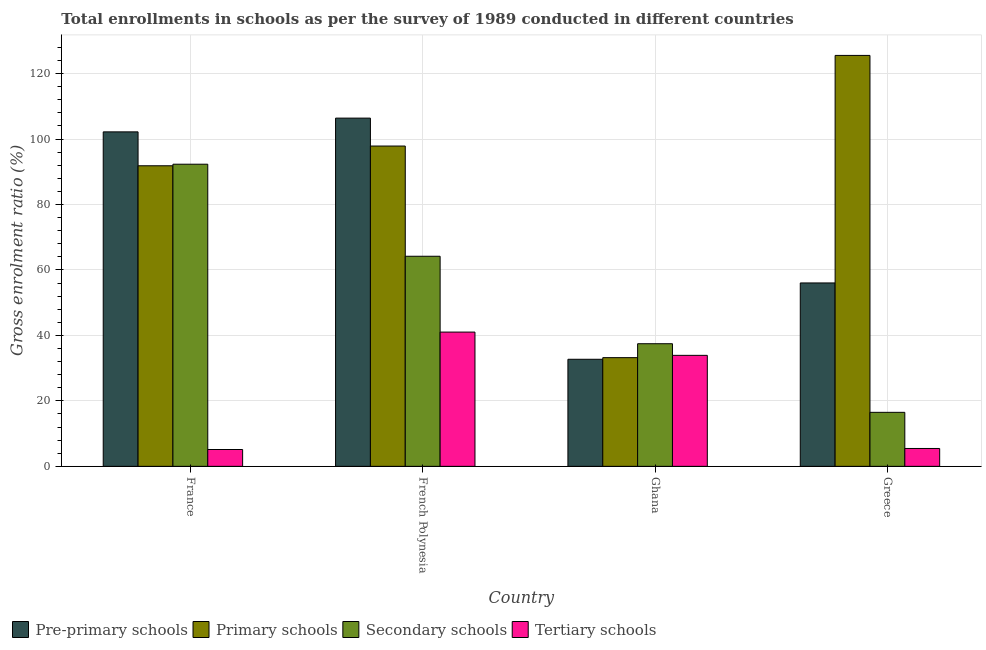How many bars are there on the 4th tick from the left?
Provide a short and direct response. 4. What is the label of the 3rd group of bars from the left?
Give a very brief answer. Ghana. In how many cases, is the number of bars for a given country not equal to the number of legend labels?
Provide a succinct answer. 0. What is the gross enrolment ratio in primary schools in French Polynesia?
Your answer should be very brief. 97.86. Across all countries, what is the maximum gross enrolment ratio in pre-primary schools?
Provide a succinct answer. 106.39. Across all countries, what is the minimum gross enrolment ratio in secondary schools?
Ensure brevity in your answer.  16.5. In which country was the gross enrolment ratio in secondary schools maximum?
Make the answer very short. France. What is the total gross enrolment ratio in pre-primary schools in the graph?
Offer a terse response. 297.32. What is the difference between the gross enrolment ratio in secondary schools in Ghana and that in Greece?
Your answer should be very brief. 20.96. What is the difference between the gross enrolment ratio in secondary schools in Ghana and the gross enrolment ratio in pre-primary schools in France?
Your answer should be very brief. -64.73. What is the average gross enrolment ratio in tertiary schools per country?
Offer a very short reply. 21.38. What is the difference between the gross enrolment ratio in secondary schools and gross enrolment ratio in primary schools in French Polynesia?
Your answer should be very brief. -33.67. In how many countries, is the gross enrolment ratio in tertiary schools greater than 88 %?
Your answer should be compact. 0. What is the ratio of the gross enrolment ratio in pre-primary schools in Ghana to that in Greece?
Your answer should be compact. 0.58. Is the gross enrolment ratio in primary schools in French Polynesia less than that in Greece?
Offer a very short reply. Yes. Is the difference between the gross enrolment ratio in secondary schools in French Polynesia and Ghana greater than the difference between the gross enrolment ratio in primary schools in French Polynesia and Ghana?
Give a very brief answer. No. What is the difference between the highest and the second highest gross enrolment ratio in primary schools?
Keep it short and to the point. 27.68. What is the difference between the highest and the lowest gross enrolment ratio in pre-primary schools?
Make the answer very short. 73.68. In how many countries, is the gross enrolment ratio in pre-primary schools greater than the average gross enrolment ratio in pre-primary schools taken over all countries?
Give a very brief answer. 2. Is the sum of the gross enrolment ratio in tertiary schools in France and Ghana greater than the maximum gross enrolment ratio in pre-primary schools across all countries?
Your answer should be very brief. No. What does the 2nd bar from the left in Ghana represents?
Provide a succinct answer. Primary schools. What does the 4th bar from the right in Ghana represents?
Keep it short and to the point. Pre-primary schools. Is it the case that in every country, the sum of the gross enrolment ratio in pre-primary schools and gross enrolment ratio in primary schools is greater than the gross enrolment ratio in secondary schools?
Offer a very short reply. Yes. Does the graph contain grids?
Offer a terse response. Yes. How many legend labels are there?
Make the answer very short. 4. How are the legend labels stacked?
Offer a terse response. Horizontal. What is the title of the graph?
Offer a very short reply. Total enrollments in schools as per the survey of 1989 conducted in different countries. Does "Revenue mobilization" appear as one of the legend labels in the graph?
Provide a short and direct response. No. What is the label or title of the X-axis?
Give a very brief answer. Country. What is the label or title of the Y-axis?
Ensure brevity in your answer.  Gross enrolment ratio (%). What is the Gross enrolment ratio (%) of Pre-primary schools in France?
Offer a very short reply. 102.19. What is the Gross enrolment ratio (%) of Primary schools in France?
Your answer should be very brief. 91.83. What is the Gross enrolment ratio (%) in Secondary schools in France?
Ensure brevity in your answer.  92.31. What is the Gross enrolment ratio (%) in Tertiary schools in France?
Provide a short and direct response. 5.14. What is the Gross enrolment ratio (%) in Pre-primary schools in French Polynesia?
Provide a succinct answer. 106.39. What is the Gross enrolment ratio (%) of Primary schools in French Polynesia?
Offer a terse response. 97.86. What is the Gross enrolment ratio (%) of Secondary schools in French Polynesia?
Make the answer very short. 64.19. What is the Gross enrolment ratio (%) of Tertiary schools in French Polynesia?
Provide a succinct answer. 41.02. What is the Gross enrolment ratio (%) in Pre-primary schools in Ghana?
Your response must be concise. 32.71. What is the Gross enrolment ratio (%) in Primary schools in Ghana?
Make the answer very short. 33.21. What is the Gross enrolment ratio (%) in Secondary schools in Ghana?
Offer a very short reply. 37.46. What is the Gross enrolment ratio (%) in Tertiary schools in Ghana?
Offer a very short reply. 33.91. What is the Gross enrolment ratio (%) in Pre-primary schools in Greece?
Your answer should be very brief. 56.03. What is the Gross enrolment ratio (%) in Primary schools in Greece?
Ensure brevity in your answer.  125.54. What is the Gross enrolment ratio (%) of Secondary schools in Greece?
Your response must be concise. 16.5. What is the Gross enrolment ratio (%) in Tertiary schools in Greece?
Your response must be concise. 5.46. Across all countries, what is the maximum Gross enrolment ratio (%) in Pre-primary schools?
Your answer should be very brief. 106.39. Across all countries, what is the maximum Gross enrolment ratio (%) in Primary schools?
Offer a very short reply. 125.54. Across all countries, what is the maximum Gross enrolment ratio (%) in Secondary schools?
Give a very brief answer. 92.31. Across all countries, what is the maximum Gross enrolment ratio (%) of Tertiary schools?
Your response must be concise. 41.02. Across all countries, what is the minimum Gross enrolment ratio (%) of Pre-primary schools?
Provide a short and direct response. 32.71. Across all countries, what is the minimum Gross enrolment ratio (%) of Primary schools?
Keep it short and to the point. 33.21. Across all countries, what is the minimum Gross enrolment ratio (%) of Secondary schools?
Your answer should be compact. 16.5. Across all countries, what is the minimum Gross enrolment ratio (%) of Tertiary schools?
Offer a terse response. 5.14. What is the total Gross enrolment ratio (%) in Pre-primary schools in the graph?
Make the answer very short. 297.32. What is the total Gross enrolment ratio (%) in Primary schools in the graph?
Give a very brief answer. 348.44. What is the total Gross enrolment ratio (%) in Secondary schools in the graph?
Keep it short and to the point. 210.45. What is the total Gross enrolment ratio (%) of Tertiary schools in the graph?
Your answer should be very brief. 85.53. What is the difference between the Gross enrolment ratio (%) in Pre-primary schools in France and that in French Polynesia?
Give a very brief answer. -4.2. What is the difference between the Gross enrolment ratio (%) of Primary schools in France and that in French Polynesia?
Ensure brevity in your answer.  -6.03. What is the difference between the Gross enrolment ratio (%) of Secondary schools in France and that in French Polynesia?
Offer a very short reply. 28.12. What is the difference between the Gross enrolment ratio (%) in Tertiary schools in France and that in French Polynesia?
Your answer should be very brief. -35.88. What is the difference between the Gross enrolment ratio (%) of Pre-primary schools in France and that in Ghana?
Your answer should be compact. 69.48. What is the difference between the Gross enrolment ratio (%) of Primary schools in France and that in Ghana?
Offer a very short reply. 58.62. What is the difference between the Gross enrolment ratio (%) in Secondary schools in France and that in Ghana?
Offer a terse response. 54.85. What is the difference between the Gross enrolment ratio (%) in Tertiary schools in France and that in Ghana?
Give a very brief answer. -28.77. What is the difference between the Gross enrolment ratio (%) of Pre-primary schools in France and that in Greece?
Give a very brief answer. 46.16. What is the difference between the Gross enrolment ratio (%) in Primary schools in France and that in Greece?
Provide a short and direct response. -33.71. What is the difference between the Gross enrolment ratio (%) of Secondary schools in France and that in Greece?
Offer a very short reply. 75.81. What is the difference between the Gross enrolment ratio (%) in Tertiary schools in France and that in Greece?
Provide a short and direct response. -0.32. What is the difference between the Gross enrolment ratio (%) in Pre-primary schools in French Polynesia and that in Ghana?
Make the answer very short. 73.68. What is the difference between the Gross enrolment ratio (%) in Primary schools in French Polynesia and that in Ghana?
Provide a succinct answer. 64.65. What is the difference between the Gross enrolment ratio (%) of Secondary schools in French Polynesia and that in Ghana?
Provide a succinct answer. 26.73. What is the difference between the Gross enrolment ratio (%) in Tertiary schools in French Polynesia and that in Ghana?
Provide a succinct answer. 7.11. What is the difference between the Gross enrolment ratio (%) of Pre-primary schools in French Polynesia and that in Greece?
Offer a terse response. 50.36. What is the difference between the Gross enrolment ratio (%) in Primary schools in French Polynesia and that in Greece?
Your answer should be very brief. -27.68. What is the difference between the Gross enrolment ratio (%) of Secondary schools in French Polynesia and that in Greece?
Offer a very short reply. 47.69. What is the difference between the Gross enrolment ratio (%) of Tertiary schools in French Polynesia and that in Greece?
Offer a very short reply. 35.56. What is the difference between the Gross enrolment ratio (%) of Pre-primary schools in Ghana and that in Greece?
Give a very brief answer. -23.32. What is the difference between the Gross enrolment ratio (%) of Primary schools in Ghana and that in Greece?
Give a very brief answer. -92.33. What is the difference between the Gross enrolment ratio (%) in Secondary schools in Ghana and that in Greece?
Provide a succinct answer. 20.96. What is the difference between the Gross enrolment ratio (%) of Tertiary schools in Ghana and that in Greece?
Give a very brief answer. 28.45. What is the difference between the Gross enrolment ratio (%) in Pre-primary schools in France and the Gross enrolment ratio (%) in Primary schools in French Polynesia?
Make the answer very short. 4.33. What is the difference between the Gross enrolment ratio (%) of Pre-primary schools in France and the Gross enrolment ratio (%) of Secondary schools in French Polynesia?
Provide a succinct answer. 38. What is the difference between the Gross enrolment ratio (%) in Pre-primary schools in France and the Gross enrolment ratio (%) in Tertiary schools in French Polynesia?
Provide a short and direct response. 61.17. What is the difference between the Gross enrolment ratio (%) in Primary schools in France and the Gross enrolment ratio (%) in Secondary schools in French Polynesia?
Your answer should be compact. 27.64. What is the difference between the Gross enrolment ratio (%) of Primary schools in France and the Gross enrolment ratio (%) of Tertiary schools in French Polynesia?
Keep it short and to the point. 50.81. What is the difference between the Gross enrolment ratio (%) of Secondary schools in France and the Gross enrolment ratio (%) of Tertiary schools in French Polynesia?
Offer a very short reply. 51.29. What is the difference between the Gross enrolment ratio (%) of Pre-primary schools in France and the Gross enrolment ratio (%) of Primary schools in Ghana?
Keep it short and to the point. 68.98. What is the difference between the Gross enrolment ratio (%) in Pre-primary schools in France and the Gross enrolment ratio (%) in Secondary schools in Ghana?
Offer a terse response. 64.73. What is the difference between the Gross enrolment ratio (%) in Pre-primary schools in France and the Gross enrolment ratio (%) in Tertiary schools in Ghana?
Provide a short and direct response. 68.28. What is the difference between the Gross enrolment ratio (%) of Primary schools in France and the Gross enrolment ratio (%) of Secondary schools in Ghana?
Offer a terse response. 54.37. What is the difference between the Gross enrolment ratio (%) of Primary schools in France and the Gross enrolment ratio (%) of Tertiary schools in Ghana?
Your answer should be very brief. 57.92. What is the difference between the Gross enrolment ratio (%) in Secondary schools in France and the Gross enrolment ratio (%) in Tertiary schools in Ghana?
Make the answer very short. 58.4. What is the difference between the Gross enrolment ratio (%) in Pre-primary schools in France and the Gross enrolment ratio (%) in Primary schools in Greece?
Keep it short and to the point. -23.35. What is the difference between the Gross enrolment ratio (%) in Pre-primary schools in France and the Gross enrolment ratio (%) in Secondary schools in Greece?
Offer a terse response. 85.69. What is the difference between the Gross enrolment ratio (%) of Pre-primary schools in France and the Gross enrolment ratio (%) of Tertiary schools in Greece?
Provide a succinct answer. 96.73. What is the difference between the Gross enrolment ratio (%) in Primary schools in France and the Gross enrolment ratio (%) in Secondary schools in Greece?
Offer a very short reply. 75.33. What is the difference between the Gross enrolment ratio (%) of Primary schools in France and the Gross enrolment ratio (%) of Tertiary schools in Greece?
Offer a very short reply. 86.37. What is the difference between the Gross enrolment ratio (%) of Secondary schools in France and the Gross enrolment ratio (%) of Tertiary schools in Greece?
Your answer should be very brief. 86.85. What is the difference between the Gross enrolment ratio (%) of Pre-primary schools in French Polynesia and the Gross enrolment ratio (%) of Primary schools in Ghana?
Offer a terse response. 73.18. What is the difference between the Gross enrolment ratio (%) in Pre-primary schools in French Polynesia and the Gross enrolment ratio (%) in Secondary schools in Ghana?
Your answer should be very brief. 68.93. What is the difference between the Gross enrolment ratio (%) of Pre-primary schools in French Polynesia and the Gross enrolment ratio (%) of Tertiary schools in Ghana?
Provide a short and direct response. 72.48. What is the difference between the Gross enrolment ratio (%) in Primary schools in French Polynesia and the Gross enrolment ratio (%) in Secondary schools in Ghana?
Your response must be concise. 60.4. What is the difference between the Gross enrolment ratio (%) in Primary schools in French Polynesia and the Gross enrolment ratio (%) in Tertiary schools in Ghana?
Your answer should be very brief. 63.95. What is the difference between the Gross enrolment ratio (%) of Secondary schools in French Polynesia and the Gross enrolment ratio (%) of Tertiary schools in Ghana?
Offer a terse response. 30.27. What is the difference between the Gross enrolment ratio (%) of Pre-primary schools in French Polynesia and the Gross enrolment ratio (%) of Primary schools in Greece?
Provide a short and direct response. -19.15. What is the difference between the Gross enrolment ratio (%) of Pre-primary schools in French Polynesia and the Gross enrolment ratio (%) of Secondary schools in Greece?
Ensure brevity in your answer.  89.89. What is the difference between the Gross enrolment ratio (%) of Pre-primary schools in French Polynesia and the Gross enrolment ratio (%) of Tertiary schools in Greece?
Offer a very short reply. 100.93. What is the difference between the Gross enrolment ratio (%) of Primary schools in French Polynesia and the Gross enrolment ratio (%) of Secondary schools in Greece?
Your answer should be very brief. 81.36. What is the difference between the Gross enrolment ratio (%) in Primary schools in French Polynesia and the Gross enrolment ratio (%) in Tertiary schools in Greece?
Provide a short and direct response. 92.4. What is the difference between the Gross enrolment ratio (%) of Secondary schools in French Polynesia and the Gross enrolment ratio (%) of Tertiary schools in Greece?
Offer a terse response. 58.72. What is the difference between the Gross enrolment ratio (%) in Pre-primary schools in Ghana and the Gross enrolment ratio (%) in Primary schools in Greece?
Your answer should be very brief. -92.83. What is the difference between the Gross enrolment ratio (%) of Pre-primary schools in Ghana and the Gross enrolment ratio (%) of Secondary schools in Greece?
Your response must be concise. 16.21. What is the difference between the Gross enrolment ratio (%) of Pre-primary schools in Ghana and the Gross enrolment ratio (%) of Tertiary schools in Greece?
Keep it short and to the point. 27.25. What is the difference between the Gross enrolment ratio (%) in Primary schools in Ghana and the Gross enrolment ratio (%) in Secondary schools in Greece?
Your answer should be compact. 16.71. What is the difference between the Gross enrolment ratio (%) in Primary schools in Ghana and the Gross enrolment ratio (%) in Tertiary schools in Greece?
Make the answer very short. 27.75. What is the difference between the Gross enrolment ratio (%) in Secondary schools in Ghana and the Gross enrolment ratio (%) in Tertiary schools in Greece?
Make the answer very short. 32. What is the average Gross enrolment ratio (%) of Pre-primary schools per country?
Offer a very short reply. 74.33. What is the average Gross enrolment ratio (%) of Primary schools per country?
Give a very brief answer. 87.11. What is the average Gross enrolment ratio (%) in Secondary schools per country?
Provide a short and direct response. 52.61. What is the average Gross enrolment ratio (%) in Tertiary schools per country?
Your response must be concise. 21.38. What is the difference between the Gross enrolment ratio (%) in Pre-primary schools and Gross enrolment ratio (%) in Primary schools in France?
Your answer should be very brief. 10.36. What is the difference between the Gross enrolment ratio (%) of Pre-primary schools and Gross enrolment ratio (%) of Secondary schools in France?
Your answer should be compact. 9.88. What is the difference between the Gross enrolment ratio (%) of Pre-primary schools and Gross enrolment ratio (%) of Tertiary schools in France?
Offer a terse response. 97.04. What is the difference between the Gross enrolment ratio (%) of Primary schools and Gross enrolment ratio (%) of Secondary schools in France?
Ensure brevity in your answer.  -0.48. What is the difference between the Gross enrolment ratio (%) of Primary schools and Gross enrolment ratio (%) of Tertiary schools in France?
Your answer should be compact. 86.69. What is the difference between the Gross enrolment ratio (%) in Secondary schools and Gross enrolment ratio (%) in Tertiary schools in France?
Provide a succinct answer. 87.16. What is the difference between the Gross enrolment ratio (%) of Pre-primary schools and Gross enrolment ratio (%) of Primary schools in French Polynesia?
Offer a terse response. 8.53. What is the difference between the Gross enrolment ratio (%) of Pre-primary schools and Gross enrolment ratio (%) of Secondary schools in French Polynesia?
Your answer should be compact. 42.2. What is the difference between the Gross enrolment ratio (%) in Pre-primary schools and Gross enrolment ratio (%) in Tertiary schools in French Polynesia?
Your answer should be compact. 65.37. What is the difference between the Gross enrolment ratio (%) in Primary schools and Gross enrolment ratio (%) in Secondary schools in French Polynesia?
Keep it short and to the point. 33.67. What is the difference between the Gross enrolment ratio (%) of Primary schools and Gross enrolment ratio (%) of Tertiary schools in French Polynesia?
Offer a very short reply. 56.84. What is the difference between the Gross enrolment ratio (%) in Secondary schools and Gross enrolment ratio (%) in Tertiary schools in French Polynesia?
Offer a terse response. 23.17. What is the difference between the Gross enrolment ratio (%) in Pre-primary schools and Gross enrolment ratio (%) in Primary schools in Ghana?
Make the answer very short. -0.5. What is the difference between the Gross enrolment ratio (%) of Pre-primary schools and Gross enrolment ratio (%) of Secondary schools in Ghana?
Your answer should be very brief. -4.75. What is the difference between the Gross enrolment ratio (%) in Pre-primary schools and Gross enrolment ratio (%) in Tertiary schools in Ghana?
Your answer should be compact. -1.2. What is the difference between the Gross enrolment ratio (%) of Primary schools and Gross enrolment ratio (%) of Secondary schools in Ghana?
Offer a very short reply. -4.25. What is the difference between the Gross enrolment ratio (%) of Primary schools and Gross enrolment ratio (%) of Tertiary schools in Ghana?
Your answer should be very brief. -0.7. What is the difference between the Gross enrolment ratio (%) of Secondary schools and Gross enrolment ratio (%) of Tertiary schools in Ghana?
Your response must be concise. 3.55. What is the difference between the Gross enrolment ratio (%) of Pre-primary schools and Gross enrolment ratio (%) of Primary schools in Greece?
Keep it short and to the point. -69.51. What is the difference between the Gross enrolment ratio (%) in Pre-primary schools and Gross enrolment ratio (%) in Secondary schools in Greece?
Keep it short and to the point. 39.53. What is the difference between the Gross enrolment ratio (%) of Pre-primary schools and Gross enrolment ratio (%) of Tertiary schools in Greece?
Provide a short and direct response. 50.57. What is the difference between the Gross enrolment ratio (%) of Primary schools and Gross enrolment ratio (%) of Secondary schools in Greece?
Keep it short and to the point. 109.04. What is the difference between the Gross enrolment ratio (%) in Primary schools and Gross enrolment ratio (%) in Tertiary schools in Greece?
Your response must be concise. 120.08. What is the difference between the Gross enrolment ratio (%) in Secondary schools and Gross enrolment ratio (%) in Tertiary schools in Greece?
Your answer should be very brief. 11.04. What is the ratio of the Gross enrolment ratio (%) of Pre-primary schools in France to that in French Polynesia?
Your answer should be very brief. 0.96. What is the ratio of the Gross enrolment ratio (%) in Primary schools in France to that in French Polynesia?
Your response must be concise. 0.94. What is the ratio of the Gross enrolment ratio (%) of Secondary schools in France to that in French Polynesia?
Give a very brief answer. 1.44. What is the ratio of the Gross enrolment ratio (%) in Tertiary schools in France to that in French Polynesia?
Offer a terse response. 0.13. What is the ratio of the Gross enrolment ratio (%) of Pre-primary schools in France to that in Ghana?
Give a very brief answer. 3.12. What is the ratio of the Gross enrolment ratio (%) in Primary schools in France to that in Ghana?
Offer a very short reply. 2.77. What is the ratio of the Gross enrolment ratio (%) of Secondary schools in France to that in Ghana?
Give a very brief answer. 2.46. What is the ratio of the Gross enrolment ratio (%) in Tertiary schools in France to that in Ghana?
Give a very brief answer. 0.15. What is the ratio of the Gross enrolment ratio (%) of Pre-primary schools in France to that in Greece?
Offer a terse response. 1.82. What is the ratio of the Gross enrolment ratio (%) in Primary schools in France to that in Greece?
Give a very brief answer. 0.73. What is the ratio of the Gross enrolment ratio (%) of Secondary schools in France to that in Greece?
Your answer should be compact. 5.59. What is the ratio of the Gross enrolment ratio (%) of Tertiary schools in France to that in Greece?
Ensure brevity in your answer.  0.94. What is the ratio of the Gross enrolment ratio (%) in Pre-primary schools in French Polynesia to that in Ghana?
Offer a very short reply. 3.25. What is the ratio of the Gross enrolment ratio (%) of Primary schools in French Polynesia to that in Ghana?
Offer a very short reply. 2.95. What is the ratio of the Gross enrolment ratio (%) in Secondary schools in French Polynesia to that in Ghana?
Your answer should be compact. 1.71. What is the ratio of the Gross enrolment ratio (%) of Tertiary schools in French Polynesia to that in Ghana?
Your response must be concise. 1.21. What is the ratio of the Gross enrolment ratio (%) of Pre-primary schools in French Polynesia to that in Greece?
Provide a succinct answer. 1.9. What is the ratio of the Gross enrolment ratio (%) of Primary schools in French Polynesia to that in Greece?
Offer a terse response. 0.78. What is the ratio of the Gross enrolment ratio (%) of Secondary schools in French Polynesia to that in Greece?
Provide a short and direct response. 3.89. What is the ratio of the Gross enrolment ratio (%) of Tertiary schools in French Polynesia to that in Greece?
Provide a succinct answer. 7.51. What is the ratio of the Gross enrolment ratio (%) of Pre-primary schools in Ghana to that in Greece?
Your response must be concise. 0.58. What is the ratio of the Gross enrolment ratio (%) in Primary schools in Ghana to that in Greece?
Your answer should be very brief. 0.26. What is the ratio of the Gross enrolment ratio (%) in Secondary schools in Ghana to that in Greece?
Your response must be concise. 2.27. What is the ratio of the Gross enrolment ratio (%) of Tertiary schools in Ghana to that in Greece?
Offer a very short reply. 6.21. What is the difference between the highest and the second highest Gross enrolment ratio (%) of Pre-primary schools?
Offer a terse response. 4.2. What is the difference between the highest and the second highest Gross enrolment ratio (%) of Primary schools?
Provide a short and direct response. 27.68. What is the difference between the highest and the second highest Gross enrolment ratio (%) in Secondary schools?
Make the answer very short. 28.12. What is the difference between the highest and the second highest Gross enrolment ratio (%) of Tertiary schools?
Your response must be concise. 7.11. What is the difference between the highest and the lowest Gross enrolment ratio (%) of Pre-primary schools?
Your response must be concise. 73.68. What is the difference between the highest and the lowest Gross enrolment ratio (%) of Primary schools?
Make the answer very short. 92.33. What is the difference between the highest and the lowest Gross enrolment ratio (%) in Secondary schools?
Your answer should be compact. 75.81. What is the difference between the highest and the lowest Gross enrolment ratio (%) of Tertiary schools?
Keep it short and to the point. 35.88. 